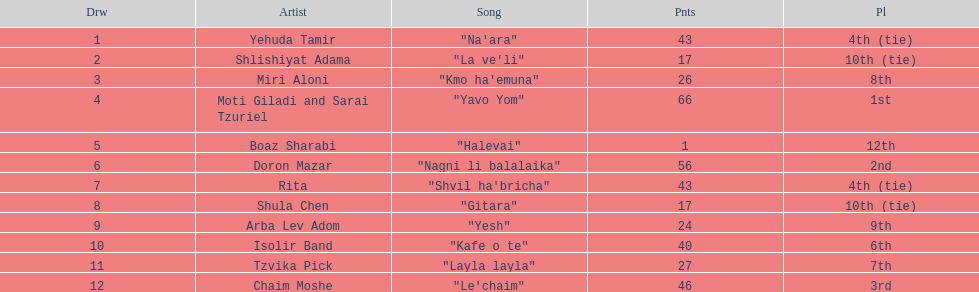What tune is indicated in the list directly before layla layla? "Kafe o te". 